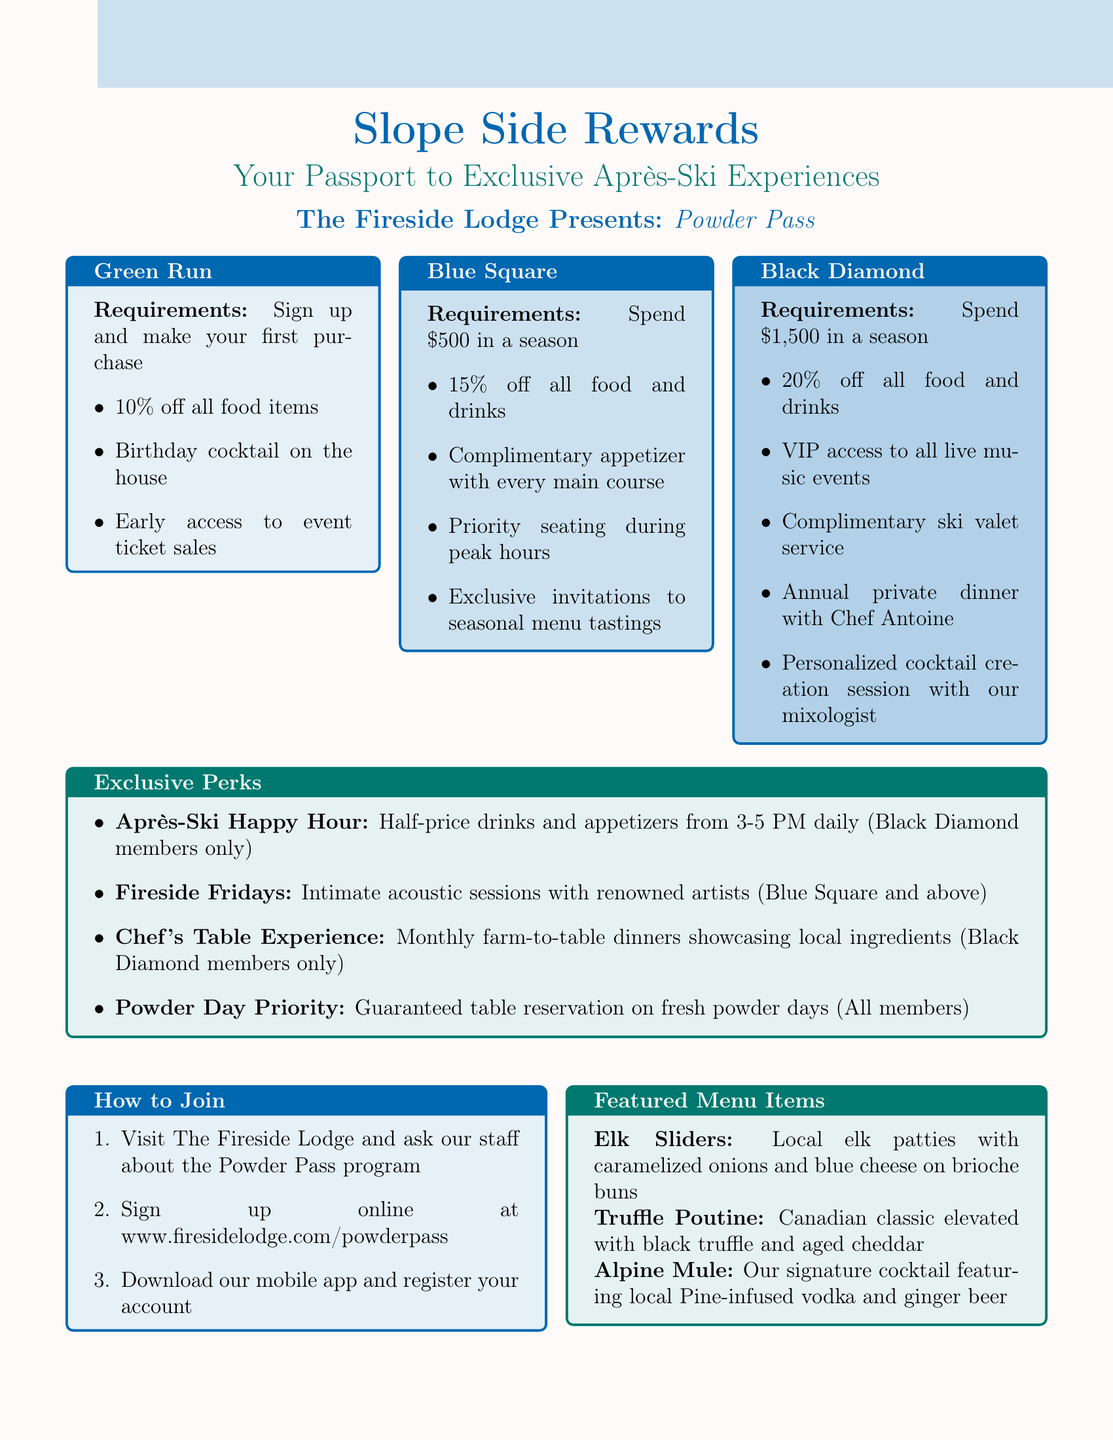What is the name of the loyalty program? The loyalty program is explicitly named in the document as "Powder Pass."
Answer: Powder Pass What is the highest membership tier? The document lists three tiers, with "Black Diamond" being the highest among them.
Answer: Black Diamond How much do you need to spend to reach Blue Square membership? The requirement for Blue Square is detailed as needing to spend $500 in a season.
Answer: $500 What exclusive event is available to Black Diamond members only? Based on the perks provided in the document, the "Chef's Table Experience" is available exclusively to Black Diamond members.
Answer: Chef's Table Experience What are the hours for the Après-Ski Happy Hour? The document specifies that the hours for this exclusive perk are from 3-5 PM daily.
Answer: 3-5 PM What benefit do all members receive on fresh powder days? The document states that all members receive "Guaranteed table reservation" on fresh powder days.
Answer: Guaranteed table reservation Who is the featured artist at the Apres-Ski Jazz Festival? The document mentions "Gregory Porter" as a featured performer at the upcoming jazz festival.
Answer: Gregory Porter How can one sign up for the Powder Pass program? Multiple methods to sign up are outlined, including signing up online or visiting the lounge; the specific method mentioned first is to visit The Fireside Lodge.
Answer: Visit The Fireside Lodge 